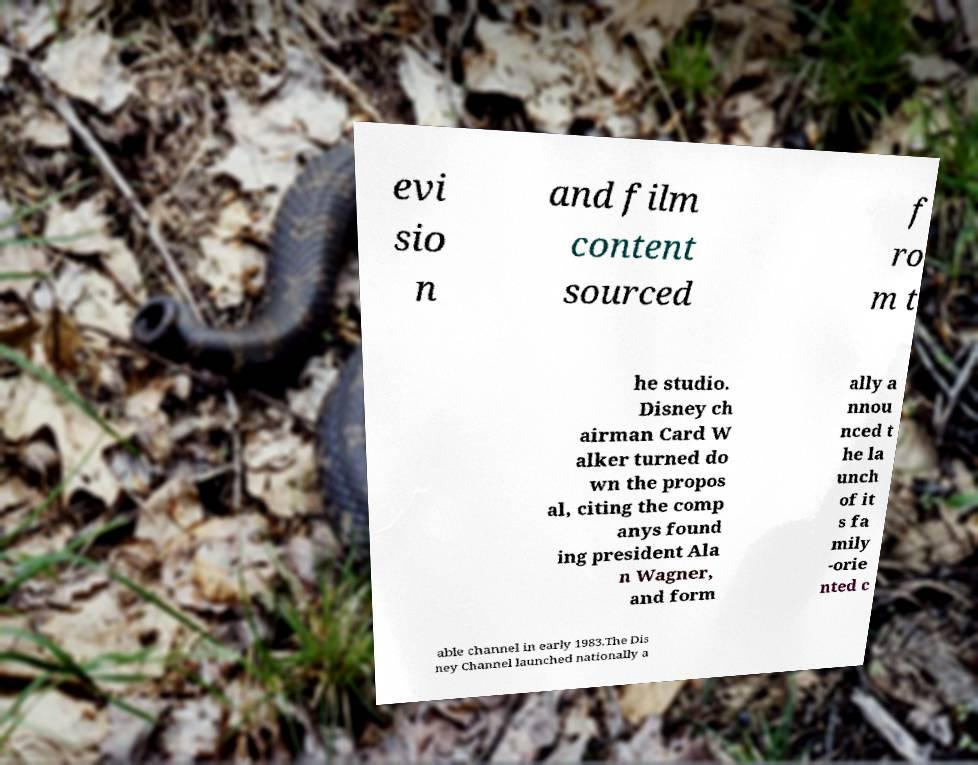Please read and relay the text visible in this image. What does it say? evi sio n and film content sourced f ro m t he studio. Disney ch airman Card W alker turned do wn the propos al, citing the comp anys found ing president Ala n Wagner, and form ally a nnou nced t he la unch of it s fa mily -orie nted c able channel in early 1983.The Dis ney Channel launched nationally a 